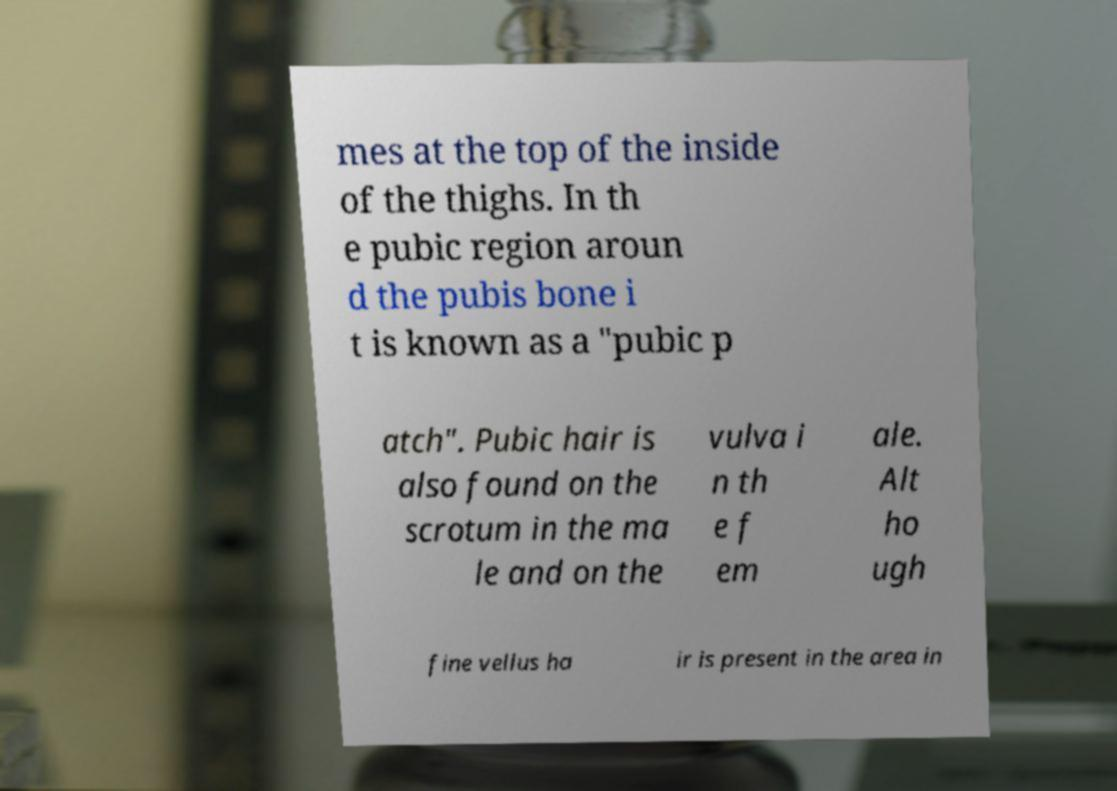Could you extract and type out the text from this image? mes at the top of the inside of the thighs. In th e pubic region aroun d the pubis bone i t is known as a "pubic p atch". Pubic hair is also found on the scrotum in the ma le and on the vulva i n th e f em ale. Alt ho ugh fine vellus ha ir is present in the area in 